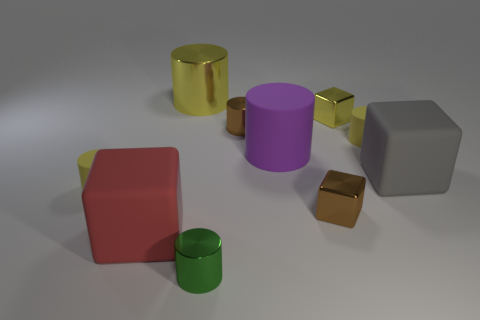Does the cylinder on the right side of the small brown shiny block have the same color as the big metal object?
Offer a terse response. Yes. Are there any shiny cubes of the same color as the large shiny cylinder?
Provide a short and direct response. Yes. Does the yellow cylinder on the right side of the purple cylinder have the same size as the green object?
Make the answer very short. Yes. Is the number of big red blocks less than the number of yellow shiny objects?
Ensure brevity in your answer.  Yes. The tiny yellow rubber object that is on the right side of the matte cylinder that is on the left side of the tiny shiny cylinder in front of the big red matte object is what shape?
Offer a terse response. Cylinder. Are there any tiny brown cylinders that have the same material as the large purple object?
Provide a short and direct response. No. There is a tiny object to the right of the small yellow metal cube; is it the same color as the cylinder that is behind the yellow cube?
Give a very brief answer. Yes. Are there fewer small cylinders behind the purple rubber object than tiny yellow things?
Ensure brevity in your answer.  Yes. What number of things are either purple spheres or metallic things behind the green shiny cylinder?
Offer a terse response. 4. What color is the large cylinder that is the same material as the red cube?
Your answer should be very brief. Purple. 